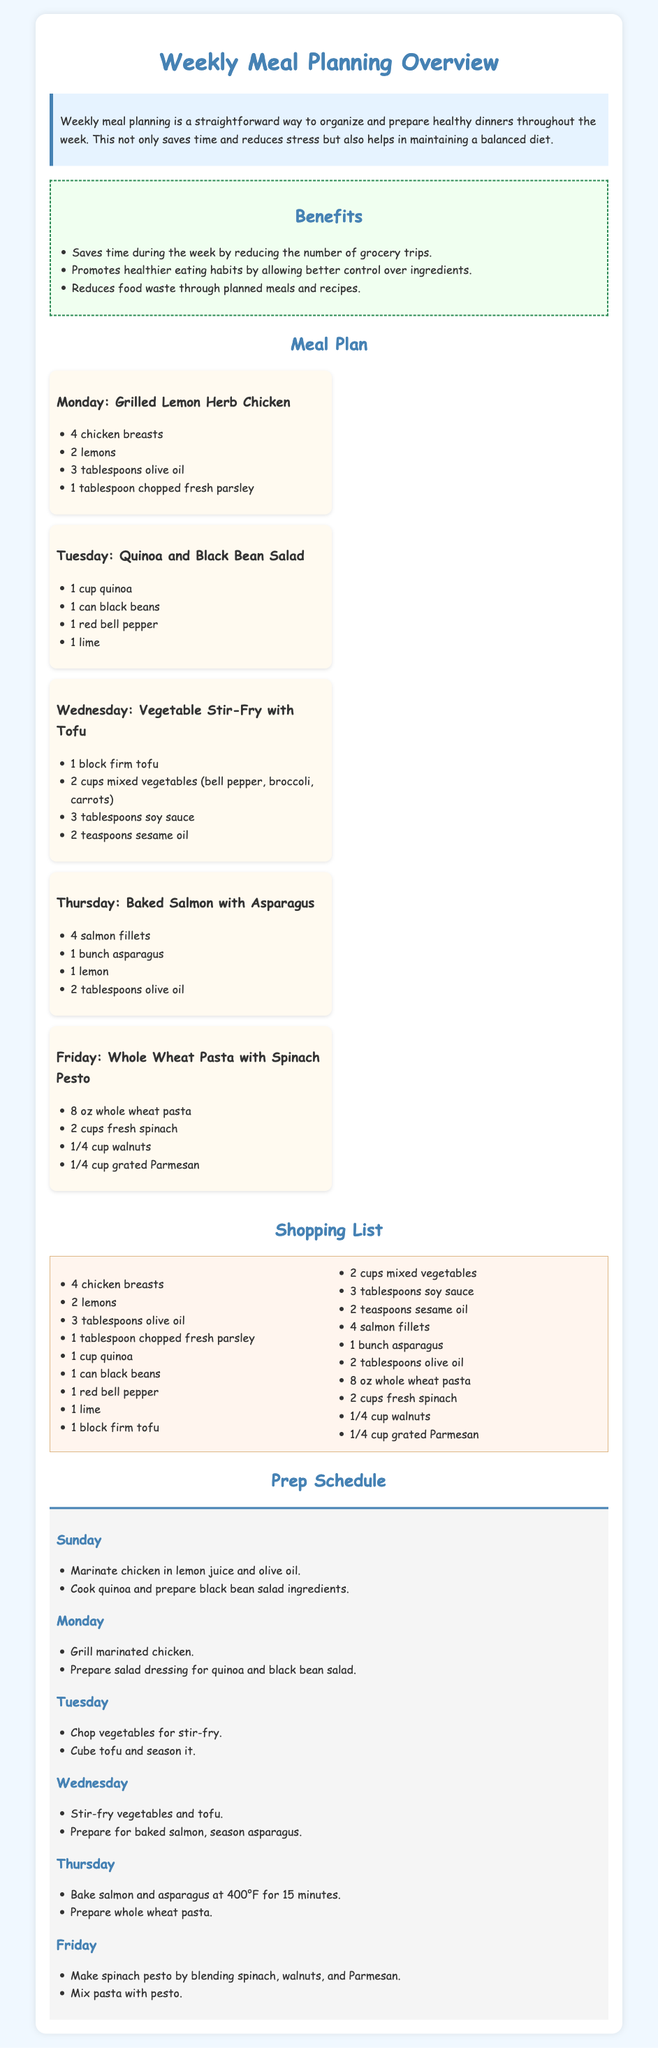what is the first dinner listed for Monday? The first dinner listed for Monday is Grilled Lemon Herb Chicken.
Answer: Grilled Lemon Herb Chicken how many cups of quinoa are needed? The meal plan specifies that 1 cup of quinoa is needed.
Answer: 1 cup what two vegetables are used in the Wednesday stir-fry? The vegetables used in the Wednesday stir-fry are bell pepper and broccoli.
Answer: bell pepper, broccoli how many salmon fillets are required for Thursday's dinner? The document states that 4 salmon fillets are required for Thursday's dinner.
Answer: 4 salmon fillets which day involves making spinach pesto? The day that involves making spinach pesto is Friday.
Answer: Friday what is the main protein used in Tuesday's meal? The main protein used in Tuesday's meal is black beans.
Answer: black beans how many tablespoons of olive oil are used for grilling chicken on Monday? On Monday, 3 tablespoons of olive oil are used for grilling chicken.
Answer: 3 tablespoons on which day should vegetables for stir-fry be chopped? The vegetables for stir-fry should be chopped on Tuesday.
Answer: Tuesday what is the total number of meals planned for the week? There are five meals planned for the week, one for each weekday.
Answer: 5 meals 